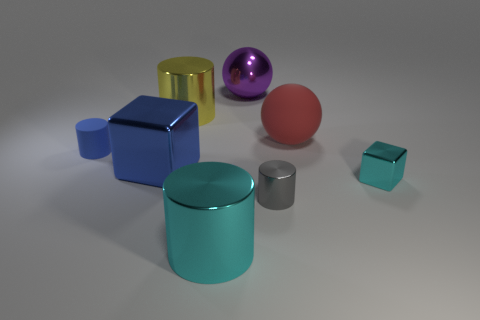What number of spheres have the same material as the large cyan object?
Ensure brevity in your answer.  1. There is a tiny cylinder that is made of the same material as the red thing; what color is it?
Ensure brevity in your answer.  Blue. There is a big yellow metallic thing; what shape is it?
Your response must be concise. Cylinder. How many small things are the same color as the big cube?
Keep it short and to the point. 1. There is a purple object that is the same size as the red matte sphere; what is its shape?
Ensure brevity in your answer.  Sphere. Is there another cyan cylinder of the same size as the cyan metal cylinder?
Offer a very short reply. No. What material is the cyan thing that is the same size as the purple thing?
Make the answer very short. Metal. There is a blue block that is behind the cyan shiny thing left of the red sphere; how big is it?
Offer a terse response. Large. Does the block that is in front of the blue shiny object have the same size as the small matte object?
Offer a very short reply. Yes. Are there more big cylinders in front of the large red sphere than large blocks to the left of the blue rubber cylinder?
Your response must be concise. Yes. 